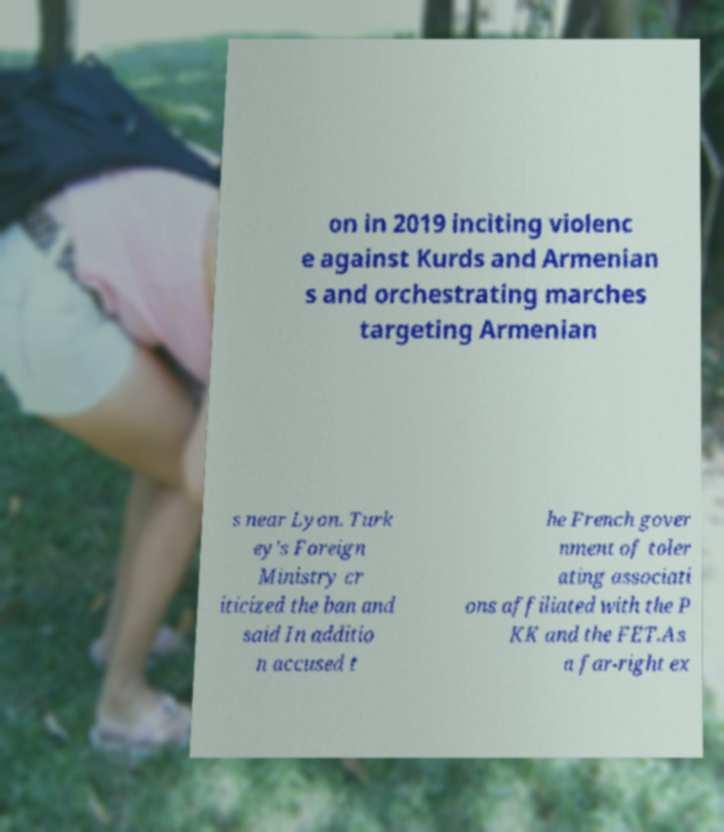Could you assist in decoding the text presented in this image and type it out clearly? on in 2019 inciting violenc e against Kurds and Armenian s and orchestrating marches targeting Armenian s near Lyon. Turk ey's Foreign Ministry cr iticized the ban and said In additio n accused t he French gover nment of toler ating associati ons affiliated with the P KK and the FET.As a far-right ex 